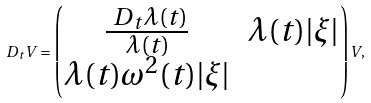<formula> <loc_0><loc_0><loc_500><loc_500>\ D _ { t } V = \begin{pmatrix} \frac { \ D _ { t } \lambda ( t ) } { \lambda ( t ) } & \lambda ( t ) | \xi | \\ \lambda ( t ) \omega ^ { 2 } ( t ) | \xi | & \end{pmatrix} V ,</formula> 